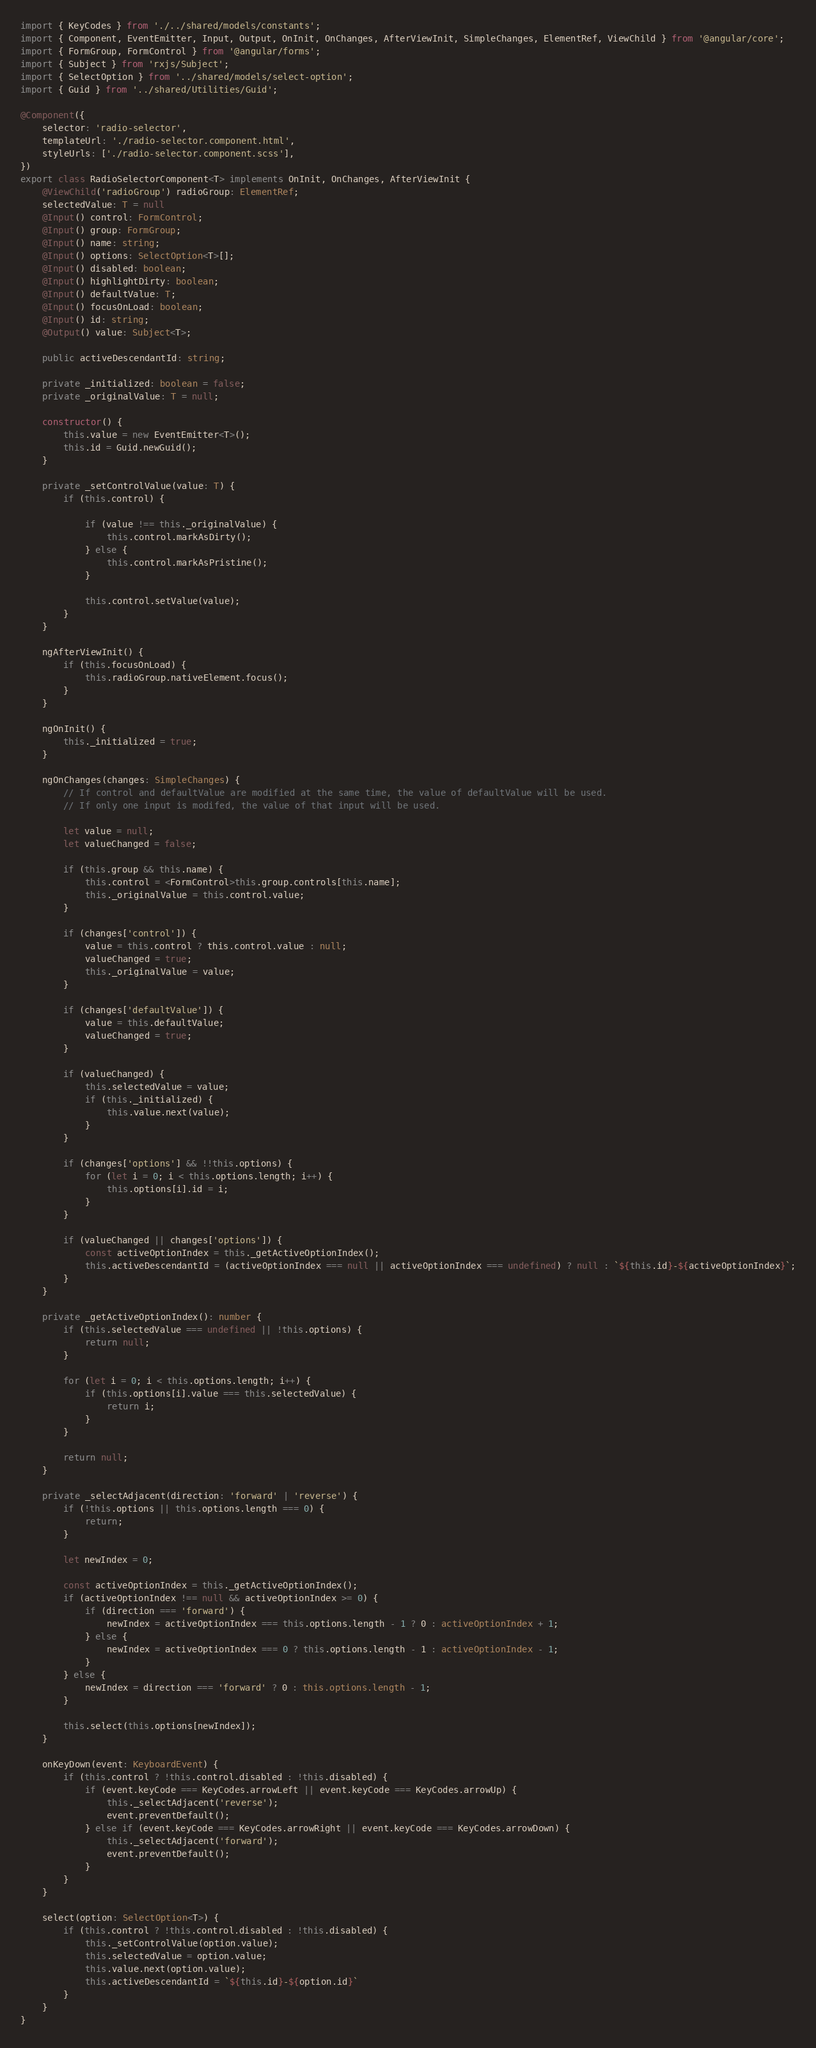Convert code to text. <code><loc_0><loc_0><loc_500><loc_500><_TypeScript_>import { KeyCodes } from './../shared/models/constants';
import { Component, EventEmitter, Input, Output, OnInit, OnChanges, AfterViewInit, SimpleChanges, ElementRef, ViewChild } from '@angular/core';
import { FormGroup, FormControl } from '@angular/forms';
import { Subject } from 'rxjs/Subject';
import { SelectOption } from '../shared/models/select-option';
import { Guid } from '../shared/Utilities/Guid';

@Component({
    selector: 'radio-selector',
    templateUrl: './radio-selector.component.html',
    styleUrls: ['./radio-selector.component.scss'],
})
export class RadioSelectorComponent<T> implements OnInit, OnChanges, AfterViewInit {
    @ViewChild('radioGroup') radioGroup: ElementRef;
    selectedValue: T = null
    @Input() control: FormControl;
    @Input() group: FormGroup;
    @Input() name: string;
    @Input() options: SelectOption<T>[];
    @Input() disabled: boolean;
    @Input() highlightDirty: boolean;
    @Input() defaultValue: T;
    @Input() focusOnLoad: boolean;
    @Input() id: string;
    @Output() value: Subject<T>;

    public activeDescendantId: string;

    private _initialized: boolean = false;
    private _originalValue: T = null;

    constructor() {
        this.value = new EventEmitter<T>();
        this.id = Guid.newGuid();
    }

    private _setControlValue(value: T) {
        if (this.control) {

            if (value !== this._originalValue) {
                this.control.markAsDirty();
            } else {
                this.control.markAsPristine();
            }

            this.control.setValue(value);
        }
    }

    ngAfterViewInit() {
        if (this.focusOnLoad) {
            this.radioGroup.nativeElement.focus();
        }
    }

    ngOnInit() {
        this._initialized = true;
    }

    ngOnChanges(changes: SimpleChanges) {
        // If control and defaultValue are modified at the same time, the value of defaultValue will be used.
        // If only one input is modifed, the value of that input will be used.

        let value = null;
        let valueChanged = false;

        if (this.group && this.name) {
            this.control = <FormControl>this.group.controls[this.name];
            this._originalValue = this.control.value;
        }

        if (changes['control']) {
            value = this.control ? this.control.value : null;
            valueChanged = true;
            this._originalValue = value;
        }

        if (changes['defaultValue']) {
            value = this.defaultValue;
            valueChanged = true;
        }

        if (valueChanged) {
            this.selectedValue = value;
            if (this._initialized) {
                this.value.next(value);
            }
        }

        if (changes['options'] && !!this.options) {
            for (let i = 0; i < this.options.length; i++) {
                this.options[i].id = i;
            }
        }

        if (valueChanged || changes['options']) {
            const activeOptionIndex = this._getActiveOptionIndex();
            this.activeDescendantId = (activeOptionIndex === null || activeOptionIndex === undefined) ? null : `${this.id}-${activeOptionIndex}`;
        }
    }

    private _getActiveOptionIndex(): number {
        if (this.selectedValue === undefined || !this.options) {
            return null;
        }

        for (let i = 0; i < this.options.length; i++) {
            if (this.options[i].value === this.selectedValue) {
                return i;
            }
        }

        return null;
    }

    private _selectAdjacent(direction: 'forward' | 'reverse') {
        if (!this.options || this.options.length === 0) {
            return;
        }

        let newIndex = 0;

        const activeOptionIndex = this._getActiveOptionIndex();
        if (activeOptionIndex !== null && activeOptionIndex >= 0) {
            if (direction === 'forward') {
                newIndex = activeOptionIndex === this.options.length - 1 ? 0 : activeOptionIndex + 1;
            } else {
                newIndex = activeOptionIndex === 0 ? this.options.length - 1 : activeOptionIndex - 1;
            }
        } else {
            newIndex = direction === 'forward' ? 0 : this.options.length - 1;
        }

        this.select(this.options[newIndex]);
    }

    onKeyDown(event: KeyboardEvent) {
        if (this.control ? !this.control.disabled : !this.disabled) {
            if (event.keyCode === KeyCodes.arrowLeft || event.keyCode === KeyCodes.arrowUp) {
                this._selectAdjacent('reverse');
                event.preventDefault();
            } else if (event.keyCode === KeyCodes.arrowRight || event.keyCode === KeyCodes.arrowDown) {
                this._selectAdjacent('forward');
                event.preventDefault();
            }
        }
    }

    select(option: SelectOption<T>) {
        if (this.control ? !this.control.disabled : !this.disabled) {
            this._setControlValue(option.value);
            this.selectedValue = option.value;
            this.value.next(option.value);
            this.activeDescendantId = `${this.id}-${option.id}`
        }
    }
}
</code> 